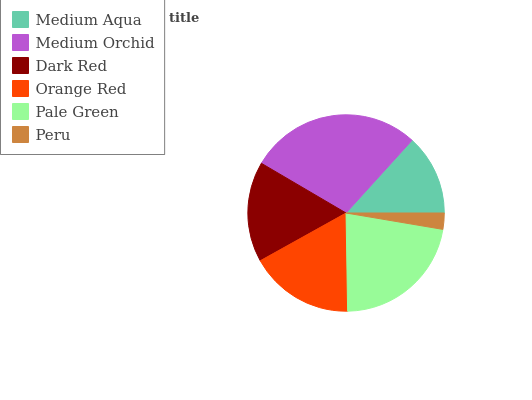Is Peru the minimum?
Answer yes or no. Yes. Is Medium Orchid the maximum?
Answer yes or no. Yes. Is Dark Red the minimum?
Answer yes or no. No. Is Dark Red the maximum?
Answer yes or no. No. Is Medium Orchid greater than Dark Red?
Answer yes or no. Yes. Is Dark Red less than Medium Orchid?
Answer yes or no. Yes. Is Dark Red greater than Medium Orchid?
Answer yes or no. No. Is Medium Orchid less than Dark Red?
Answer yes or no. No. Is Orange Red the high median?
Answer yes or no. Yes. Is Dark Red the low median?
Answer yes or no. Yes. Is Medium Orchid the high median?
Answer yes or no. No. Is Medium Orchid the low median?
Answer yes or no. No. 